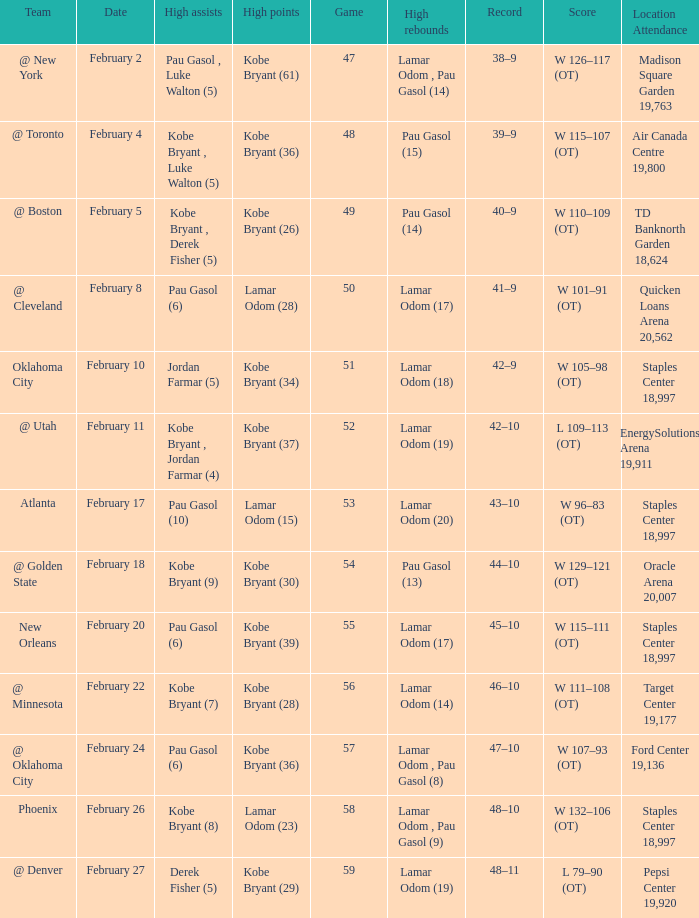Who had the most assists in the game against Atlanta? Pau Gasol (10). 